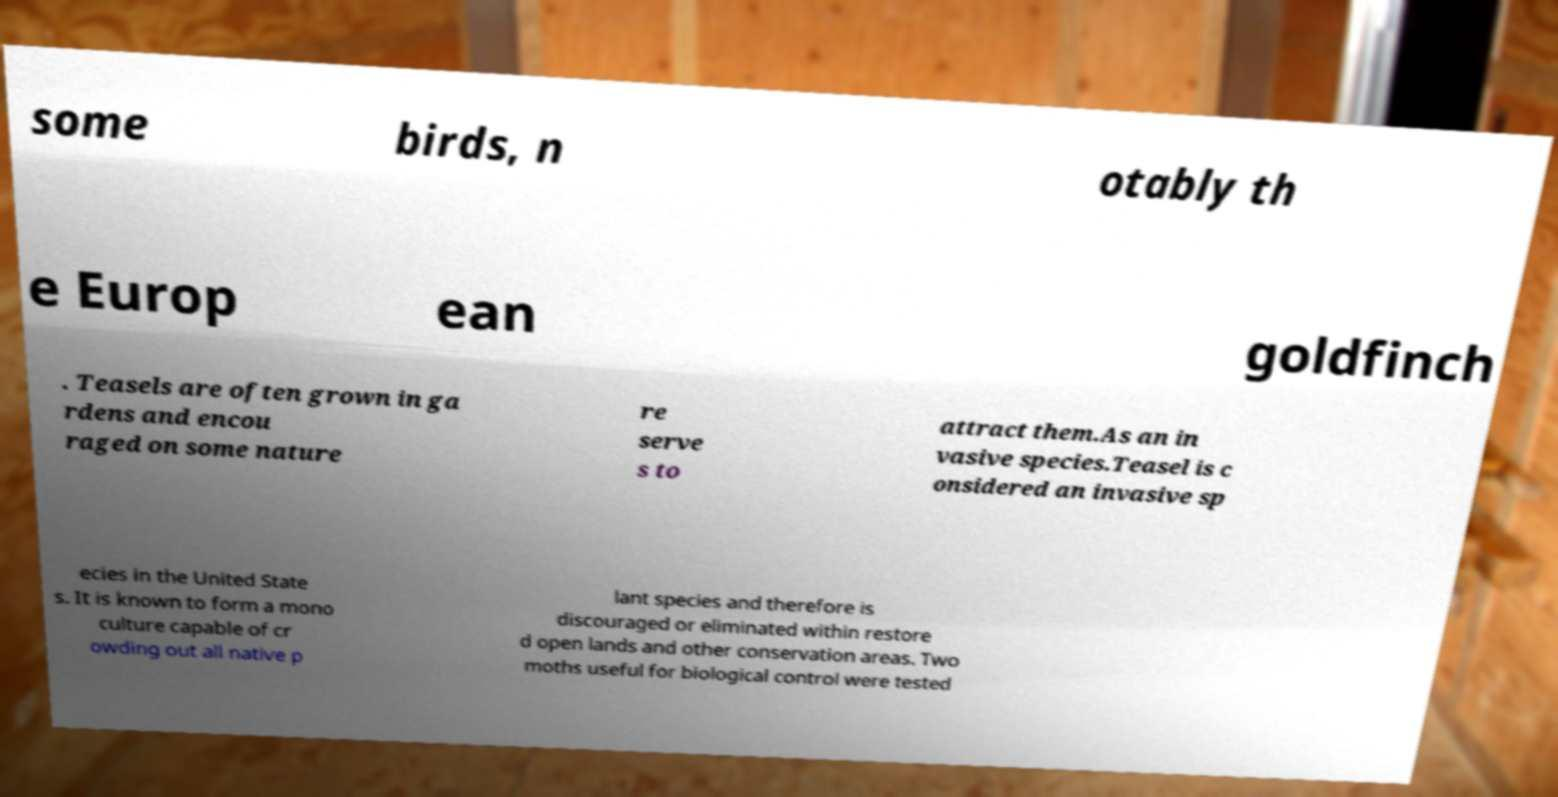Could you assist in decoding the text presented in this image and type it out clearly? some birds, n otably th e Europ ean goldfinch . Teasels are often grown in ga rdens and encou raged on some nature re serve s to attract them.As an in vasive species.Teasel is c onsidered an invasive sp ecies in the United State s. It is known to form a mono culture capable of cr owding out all native p lant species and therefore is discouraged or eliminated within restore d open lands and other conservation areas. Two moths useful for biological control were tested 